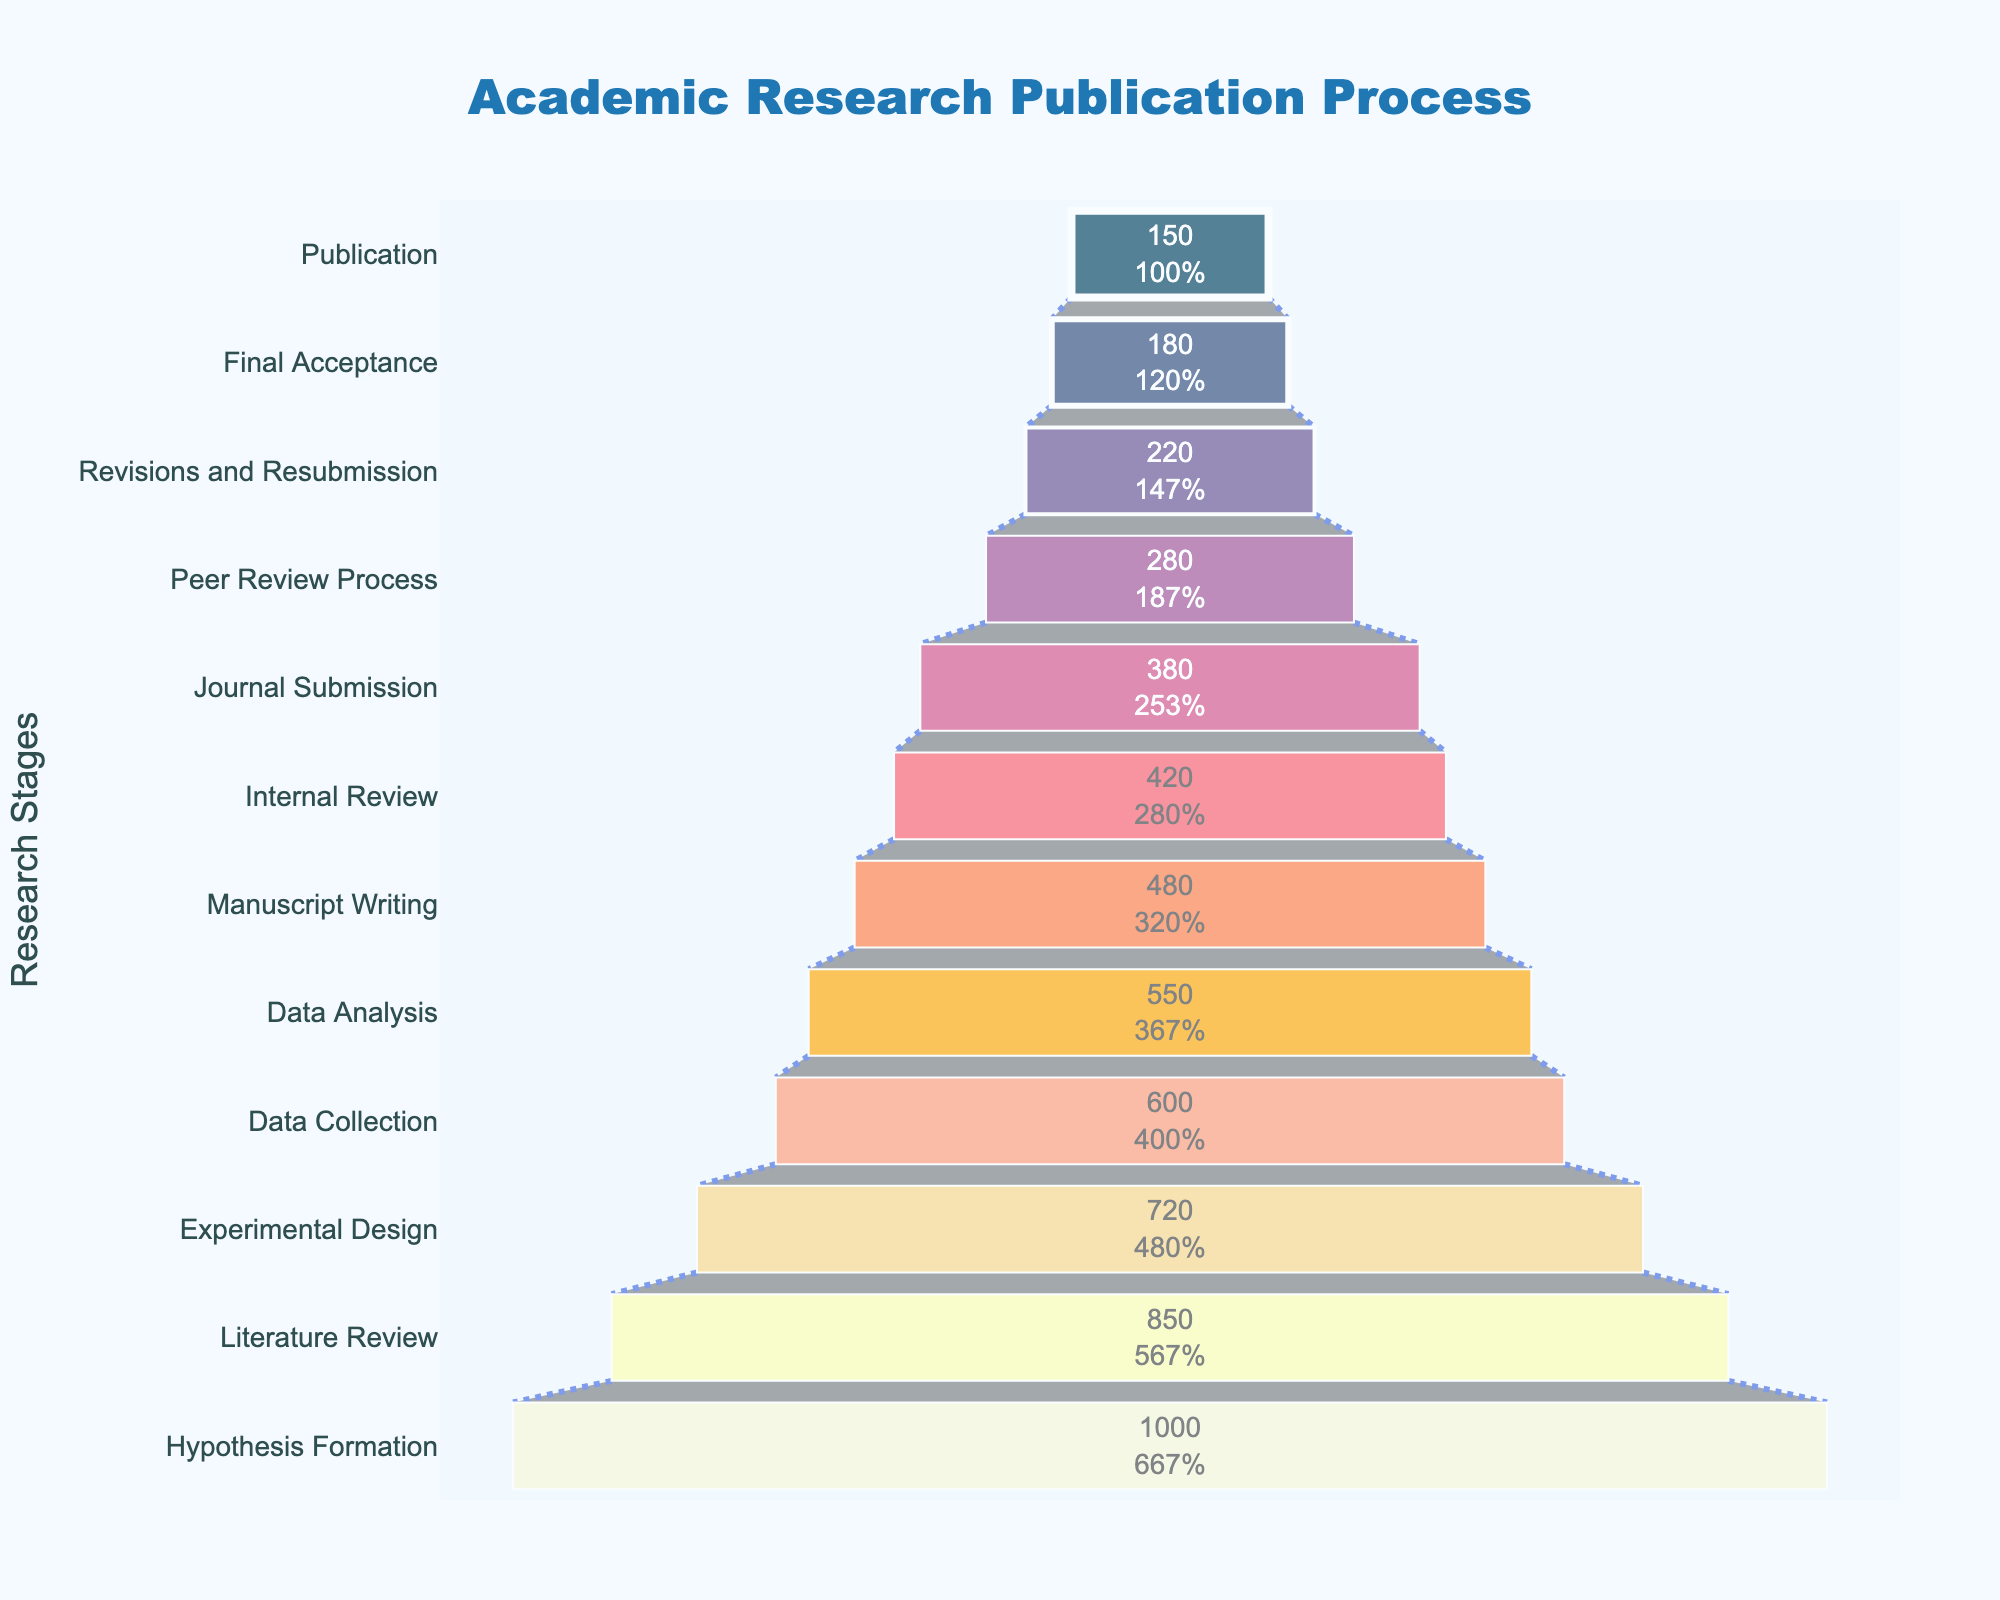Which research stage has the highest number of researchers? The stage with the highest number of researchers is "Hypothesis Formation" with 1000 researchers. This is evident as it’s the largest segment in the funnel.
Answer: Hypothesis Formation How many researchers are involved in the "Journal Submission" stage? The number of researchers involved in the "Journal Submission" stage is clearly labeled within the figure. It is 380 researchers.
Answer: 380 What is the percentage reduction in researchers from the "Hypothesis Formation" stage to the "Literature Review" stage? First, identify the number of researchers at both stages: "Hypothesis Formation" has 1000 researchers and "Literature Review" has 850. Calculate the reduction: 1000 - 850 = 150. Then, find the percentage: (150 / 1000) * 100 = 15%.
Answer: 15% Compare the number of researchers between "Data Collection" and "Internal Review". Which stage has more researchers and by how much? "Data Collection" has 600 researchers and "Internal Review" has 420. Thus, "Data Collection" has more researchers. Calculate the difference: 600 - 420 = 180.
Answer: Data Collection, 180 What is the average number of researchers from "Data Analysis" to "Final Acceptance"? Identify the stages: "Data Analysis", "Manuscript Writing", "Internal Review", "Journal Submission", "Peer Review Process", "Revisions and Resubmission", and "Final Acceptance". The number of researchers are: 550, 480, 420, 380, 280, 220, 180. Sum these and divide by the number of stages: (550 + 480 + 420 + 380 + 280 + 220 + 180) / 7 = 2510 / 7 ≈ 358.57.
Answer: 358.57 What percentage of researchers originally starting at "Hypothesis Formation" reach the "Final Acceptance" stage? The number of researchers reaching "Final Acceptance" is 180. The initial number of researchers at "Hypothesis Formation" is 1000. Calculate the percentage: (180 / 1000) * 100 = 18%.
Answer: 18% How does the number of researchers change between the "Peer Review Process" stage and the "Revisions and Resubmission" stage? "Peer Review Process" has 280 researchers and "Revisions and Resubmission" has 220. The change is 280 - 220 = 60 researchers.
Answer: Decrease, 60 Which stage experiences the greatest drop in the number of researchers compared to the previous stage? To find the stage with the greatest drop, compare each pair of consecutive stages: 
- "Hypothesis Formation" to "Literature Review": 1000 - 850 = 150
- "Literature Review" to "Experimental Design": 850 - 720 = 130
- "Experimental Design" to "Data Collection": 720 - 600 = 120
- "Data Collection" to "Data Analysis": 600 - 550 = 50
- "Data Analysis" to "Manuscript Writing": 550 - 480 = 70
- "Manuscript Writing" to "Internal Review": 480 - 420 = 60
- "Internal Review" to "Journal Submission": 420 - 380 = 40
- "Journal Submission" to "Peer Review Process": 380 - 280 = 100
- "Peer Review Process" to "Revisions and Resubmission": 280 - 220 = 60
- "Revisions and Resubmission" to "Final Acceptance": 220 - 180 = 40
The greatest drop is between "Hypothesis Formation" and "Literature Review", with 150 researchers.
Answer: Hypothesis Formation to Literature Review, 150 